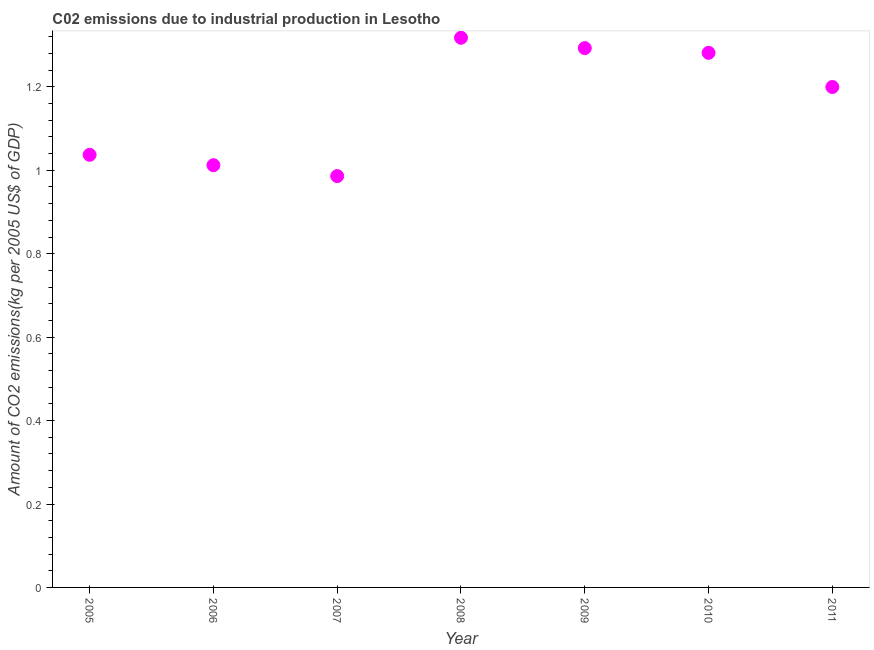What is the amount of co2 emissions in 2011?
Provide a succinct answer. 1.2. Across all years, what is the maximum amount of co2 emissions?
Your answer should be very brief. 1.32. Across all years, what is the minimum amount of co2 emissions?
Your answer should be compact. 0.99. What is the sum of the amount of co2 emissions?
Your response must be concise. 8.13. What is the difference between the amount of co2 emissions in 2008 and 2009?
Your response must be concise. 0.02. What is the average amount of co2 emissions per year?
Provide a short and direct response. 1.16. What is the median amount of co2 emissions?
Provide a short and direct response. 1.2. In how many years, is the amount of co2 emissions greater than 0.32 kg per 2005 US$ of GDP?
Your response must be concise. 7. What is the ratio of the amount of co2 emissions in 2006 to that in 2008?
Make the answer very short. 0.77. Is the amount of co2 emissions in 2007 less than that in 2010?
Offer a very short reply. Yes. What is the difference between the highest and the second highest amount of co2 emissions?
Ensure brevity in your answer.  0.02. Is the sum of the amount of co2 emissions in 2005 and 2011 greater than the maximum amount of co2 emissions across all years?
Ensure brevity in your answer.  Yes. What is the difference between the highest and the lowest amount of co2 emissions?
Your response must be concise. 0.33. Does the amount of co2 emissions monotonically increase over the years?
Give a very brief answer. No. How many dotlines are there?
Provide a short and direct response. 1. How many years are there in the graph?
Your answer should be very brief. 7. Does the graph contain grids?
Provide a short and direct response. No. What is the title of the graph?
Keep it short and to the point. C02 emissions due to industrial production in Lesotho. What is the label or title of the X-axis?
Your answer should be compact. Year. What is the label or title of the Y-axis?
Your response must be concise. Amount of CO2 emissions(kg per 2005 US$ of GDP). What is the Amount of CO2 emissions(kg per 2005 US$ of GDP) in 2005?
Make the answer very short. 1.04. What is the Amount of CO2 emissions(kg per 2005 US$ of GDP) in 2006?
Keep it short and to the point. 1.01. What is the Amount of CO2 emissions(kg per 2005 US$ of GDP) in 2007?
Ensure brevity in your answer.  0.99. What is the Amount of CO2 emissions(kg per 2005 US$ of GDP) in 2008?
Provide a succinct answer. 1.32. What is the Amount of CO2 emissions(kg per 2005 US$ of GDP) in 2009?
Make the answer very short. 1.29. What is the Amount of CO2 emissions(kg per 2005 US$ of GDP) in 2010?
Offer a very short reply. 1.28. What is the Amount of CO2 emissions(kg per 2005 US$ of GDP) in 2011?
Make the answer very short. 1.2. What is the difference between the Amount of CO2 emissions(kg per 2005 US$ of GDP) in 2005 and 2006?
Offer a very short reply. 0.02. What is the difference between the Amount of CO2 emissions(kg per 2005 US$ of GDP) in 2005 and 2007?
Make the answer very short. 0.05. What is the difference between the Amount of CO2 emissions(kg per 2005 US$ of GDP) in 2005 and 2008?
Offer a terse response. -0.28. What is the difference between the Amount of CO2 emissions(kg per 2005 US$ of GDP) in 2005 and 2009?
Ensure brevity in your answer.  -0.26. What is the difference between the Amount of CO2 emissions(kg per 2005 US$ of GDP) in 2005 and 2010?
Ensure brevity in your answer.  -0.24. What is the difference between the Amount of CO2 emissions(kg per 2005 US$ of GDP) in 2005 and 2011?
Ensure brevity in your answer.  -0.16. What is the difference between the Amount of CO2 emissions(kg per 2005 US$ of GDP) in 2006 and 2007?
Your answer should be very brief. 0.03. What is the difference between the Amount of CO2 emissions(kg per 2005 US$ of GDP) in 2006 and 2008?
Your response must be concise. -0.31. What is the difference between the Amount of CO2 emissions(kg per 2005 US$ of GDP) in 2006 and 2009?
Provide a short and direct response. -0.28. What is the difference between the Amount of CO2 emissions(kg per 2005 US$ of GDP) in 2006 and 2010?
Offer a terse response. -0.27. What is the difference between the Amount of CO2 emissions(kg per 2005 US$ of GDP) in 2006 and 2011?
Keep it short and to the point. -0.19. What is the difference between the Amount of CO2 emissions(kg per 2005 US$ of GDP) in 2007 and 2008?
Ensure brevity in your answer.  -0.33. What is the difference between the Amount of CO2 emissions(kg per 2005 US$ of GDP) in 2007 and 2009?
Make the answer very short. -0.31. What is the difference between the Amount of CO2 emissions(kg per 2005 US$ of GDP) in 2007 and 2010?
Offer a very short reply. -0.3. What is the difference between the Amount of CO2 emissions(kg per 2005 US$ of GDP) in 2007 and 2011?
Provide a succinct answer. -0.21. What is the difference between the Amount of CO2 emissions(kg per 2005 US$ of GDP) in 2008 and 2009?
Provide a short and direct response. 0.02. What is the difference between the Amount of CO2 emissions(kg per 2005 US$ of GDP) in 2008 and 2010?
Make the answer very short. 0.04. What is the difference between the Amount of CO2 emissions(kg per 2005 US$ of GDP) in 2008 and 2011?
Your answer should be very brief. 0.12. What is the difference between the Amount of CO2 emissions(kg per 2005 US$ of GDP) in 2009 and 2010?
Your response must be concise. 0.01. What is the difference between the Amount of CO2 emissions(kg per 2005 US$ of GDP) in 2009 and 2011?
Your answer should be compact. 0.09. What is the difference between the Amount of CO2 emissions(kg per 2005 US$ of GDP) in 2010 and 2011?
Give a very brief answer. 0.08. What is the ratio of the Amount of CO2 emissions(kg per 2005 US$ of GDP) in 2005 to that in 2006?
Your response must be concise. 1.02. What is the ratio of the Amount of CO2 emissions(kg per 2005 US$ of GDP) in 2005 to that in 2007?
Provide a short and direct response. 1.05. What is the ratio of the Amount of CO2 emissions(kg per 2005 US$ of GDP) in 2005 to that in 2008?
Provide a short and direct response. 0.79. What is the ratio of the Amount of CO2 emissions(kg per 2005 US$ of GDP) in 2005 to that in 2009?
Ensure brevity in your answer.  0.8. What is the ratio of the Amount of CO2 emissions(kg per 2005 US$ of GDP) in 2005 to that in 2010?
Make the answer very short. 0.81. What is the ratio of the Amount of CO2 emissions(kg per 2005 US$ of GDP) in 2005 to that in 2011?
Offer a very short reply. 0.86. What is the ratio of the Amount of CO2 emissions(kg per 2005 US$ of GDP) in 2006 to that in 2007?
Your answer should be compact. 1.03. What is the ratio of the Amount of CO2 emissions(kg per 2005 US$ of GDP) in 2006 to that in 2008?
Offer a very short reply. 0.77. What is the ratio of the Amount of CO2 emissions(kg per 2005 US$ of GDP) in 2006 to that in 2009?
Your answer should be very brief. 0.78. What is the ratio of the Amount of CO2 emissions(kg per 2005 US$ of GDP) in 2006 to that in 2010?
Give a very brief answer. 0.79. What is the ratio of the Amount of CO2 emissions(kg per 2005 US$ of GDP) in 2006 to that in 2011?
Offer a very short reply. 0.84. What is the ratio of the Amount of CO2 emissions(kg per 2005 US$ of GDP) in 2007 to that in 2008?
Your answer should be compact. 0.75. What is the ratio of the Amount of CO2 emissions(kg per 2005 US$ of GDP) in 2007 to that in 2009?
Keep it short and to the point. 0.76. What is the ratio of the Amount of CO2 emissions(kg per 2005 US$ of GDP) in 2007 to that in 2010?
Offer a very short reply. 0.77. What is the ratio of the Amount of CO2 emissions(kg per 2005 US$ of GDP) in 2007 to that in 2011?
Give a very brief answer. 0.82. What is the ratio of the Amount of CO2 emissions(kg per 2005 US$ of GDP) in 2008 to that in 2010?
Offer a very short reply. 1.03. What is the ratio of the Amount of CO2 emissions(kg per 2005 US$ of GDP) in 2008 to that in 2011?
Offer a very short reply. 1.1. What is the ratio of the Amount of CO2 emissions(kg per 2005 US$ of GDP) in 2009 to that in 2010?
Your response must be concise. 1.01. What is the ratio of the Amount of CO2 emissions(kg per 2005 US$ of GDP) in 2009 to that in 2011?
Keep it short and to the point. 1.08. What is the ratio of the Amount of CO2 emissions(kg per 2005 US$ of GDP) in 2010 to that in 2011?
Provide a short and direct response. 1.07. 